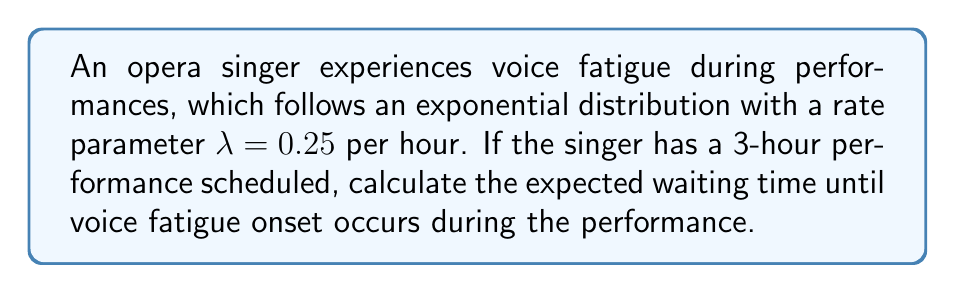Solve this math problem. To solve this problem, we'll follow these steps:

1) The exponential distribution is used to model the time until an event occurs. In this case, it's modeling the time until voice fatigue onset.

2) For an exponential distribution with rate parameter $\lambda$, the expected value (mean) is given by:

   $$E[X] = \frac{1}{\lambda}$$

3) We're given that $\lambda = 0.25$ per hour. Let's substitute this into our formula:

   $$E[X] = \frac{1}{0.25} = 4 \text{ hours}$$

4) This means that, on average, voice fatigue would onset after 4 hours of singing.

5) However, the performance is only 3 hours long. We need to calculate the expected waiting time given that the event occurs within the 3-hour performance.

6) For this, we use the formula for the expected value of a truncated exponential distribution:

   $$E[X|X \leq T] = \frac{1}{\lambda} - \frac{T}{e^{\lambda T} - 1}$$

   Where $T$ is the truncation point (in this case, 3 hours).

7) Let's substitute our values:

   $$E[X|X \leq 3] = \frac{1}{0.25} - \frac{3}{e^{0.25 \cdot 3} - 1}$$

8) Simplifying:

   $$E[X|X \leq 3] = 4 - \frac{3}{e^{0.75} - 1} \approx 2.11 \text{ hours}$$

Therefore, the expected waiting time for voice fatigue onset during the 3-hour performance is approximately 2.11 hours.
Answer: 2.11 hours 